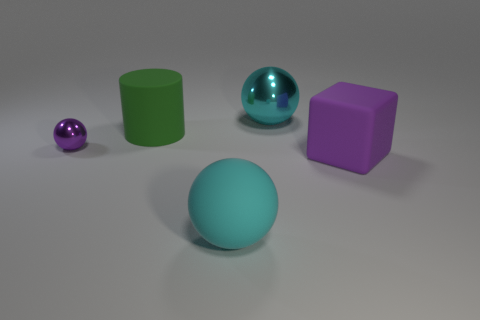Add 1 small yellow matte things. How many objects exist? 6 Subtract all cubes. How many objects are left? 4 Subtract all cyan spheres. Subtract all tiny purple balls. How many objects are left? 2 Add 5 big purple things. How many big purple things are left? 6 Add 4 big green cylinders. How many big green cylinders exist? 5 Subtract 0 red spheres. How many objects are left? 5 